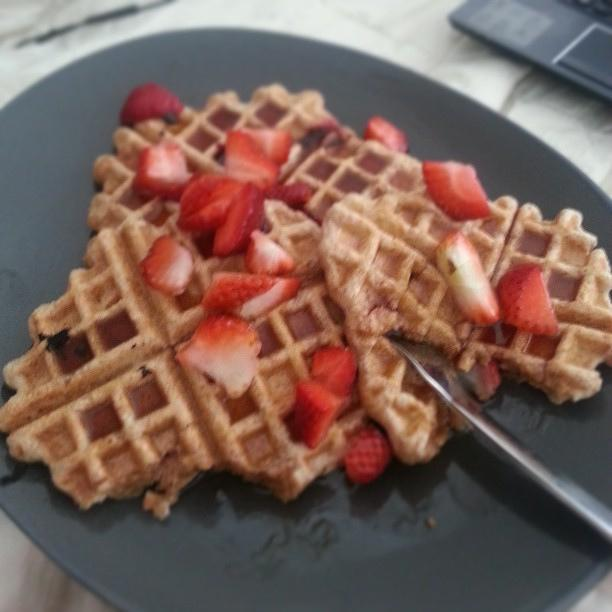What is most likely to be added to this food item?

Choices:
A) apples
B) syrup
C) milk
D) jam syrup 